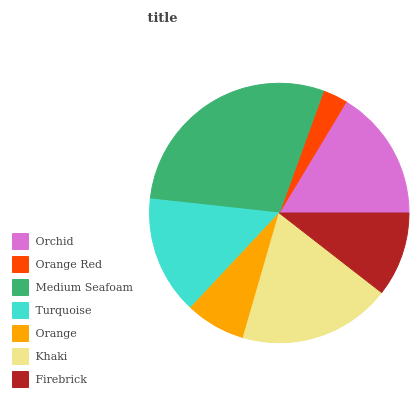Is Orange Red the minimum?
Answer yes or no. Yes. Is Medium Seafoam the maximum?
Answer yes or no. Yes. Is Medium Seafoam the minimum?
Answer yes or no. No. Is Orange Red the maximum?
Answer yes or no. No. Is Medium Seafoam greater than Orange Red?
Answer yes or no. Yes. Is Orange Red less than Medium Seafoam?
Answer yes or no. Yes. Is Orange Red greater than Medium Seafoam?
Answer yes or no. No. Is Medium Seafoam less than Orange Red?
Answer yes or no. No. Is Turquoise the high median?
Answer yes or no. Yes. Is Turquoise the low median?
Answer yes or no. Yes. Is Firebrick the high median?
Answer yes or no. No. Is Orchid the low median?
Answer yes or no. No. 